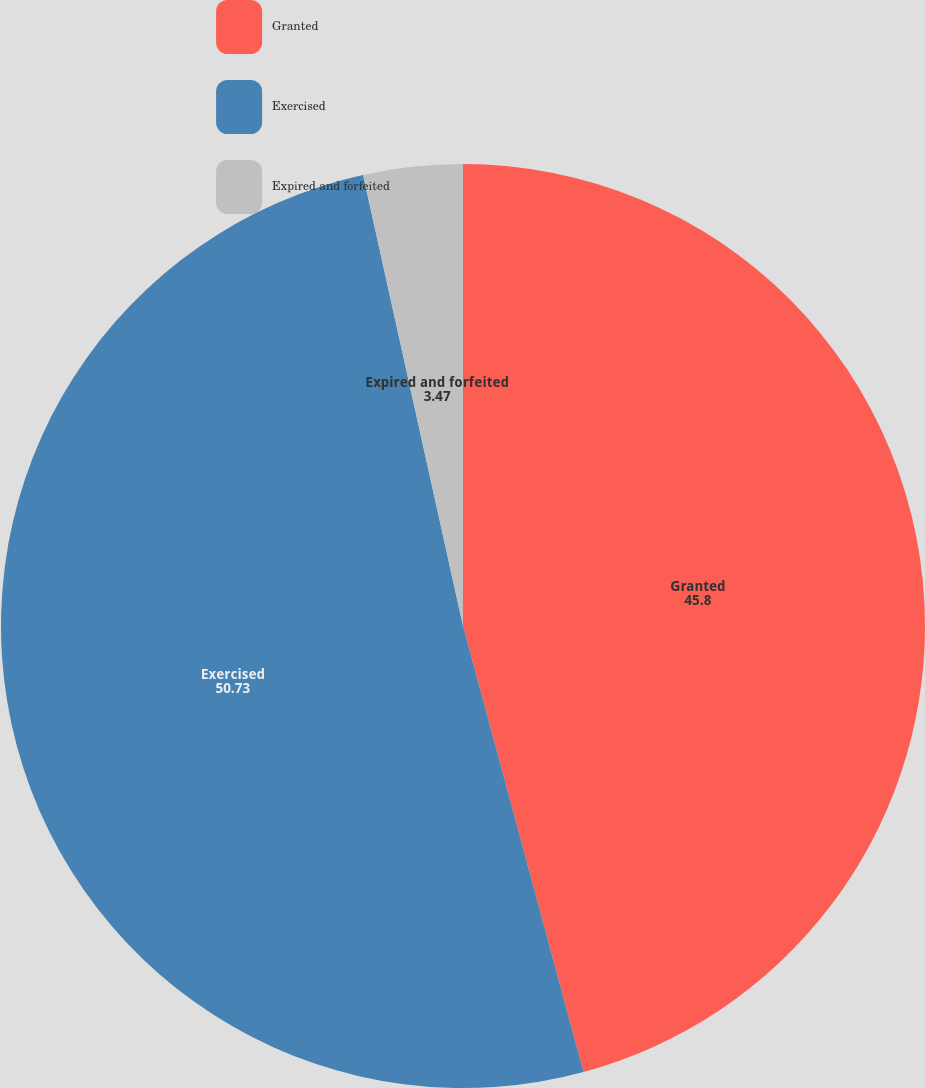<chart> <loc_0><loc_0><loc_500><loc_500><pie_chart><fcel>Granted<fcel>Exercised<fcel>Expired and forfeited<nl><fcel>45.8%<fcel>50.73%<fcel>3.47%<nl></chart> 